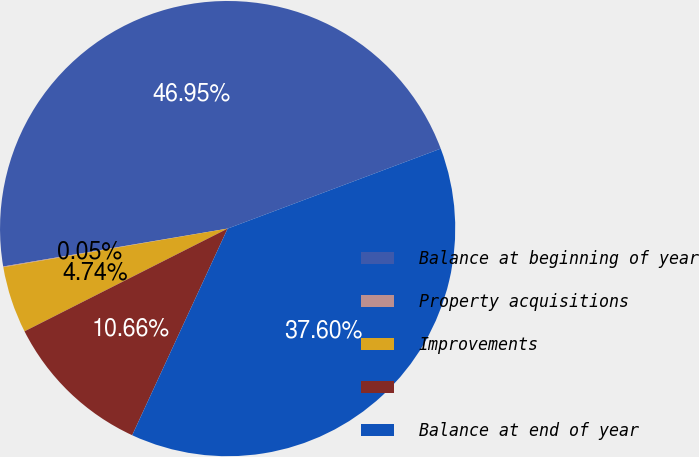Convert chart to OTSL. <chart><loc_0><loc_0><loc_500><loc_500><pie_chart><fcel>Balance at beginning of year<fcel>Property acquisitions<fcel>Improvements<fcel>Unnamed: 3<fcel>Balance at end of year<nl><fcel>46.95%<fcel>0.05%<fcel>4.74%<fcel>10.66%<fcel>37.6%<nl></chart> 